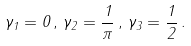Convert formula to latex. <formula><loc_0><loc_0><loc_500><loc_500>\gamma _ { 1 } = 0 \, , \, \gamma _ { 2 } = \frac { 1 } { \pi } \, , \, \gamma _ { 3 } = \frac { 1 } { 2 } \, .</formula> 